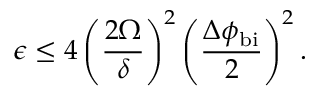Convert formula to latex. <formula><loc_0><loc_0><loc_500><loc_500>\epsilon \leq 4 \left ( \frac { 2 \Omega } { \delta } \right ) ^ { 2 } \left ( \frac { \Delta \phi _ { b i } } { 2 } \right ) ^ { 2 } .</formula> 